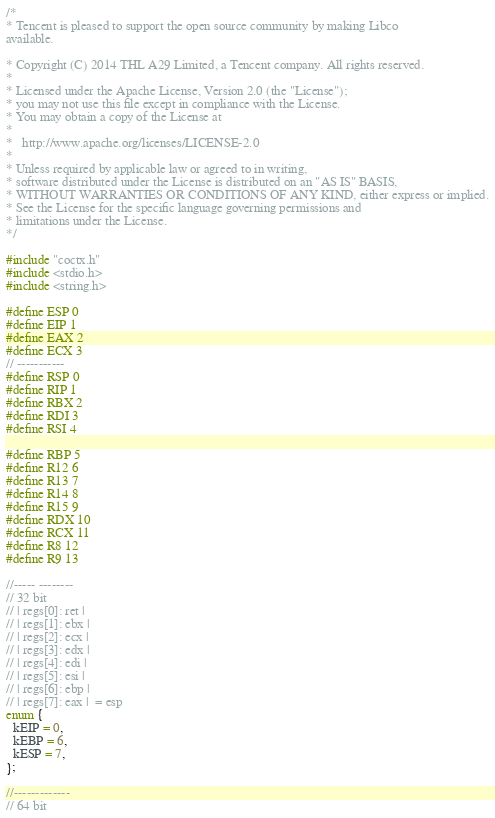<code> <loc_0><loc_0><loc_500><loc_500><_C++_>/*
* Tencent is pleased to support the open source community by making Libco
available.

* Copyright (C) 2014 THL A29 Limited, a Tencent company. All rights reserved.
*
* Licensed under the Apache License, Version 2.0 (the "License");
* you may not use this file except in compliance with the License.
* You may obtain a copy of the License at
*
*	http://www.apache.org/licenses/LICENSE-2.0
*
* Unless required by applicable law or agreed to in writing,
* software distributed under the License is distributed on an "AS IS" BASIS,
* WITHOUT WARRANTIES OR CONDITIONS OF ANY KIND, either express or implied.
* See the License for the specific language governing permissions and
* limitations under the License.
*/

#include "coctx.h"
#include <stdio.h>
#include <string.h>

#define ESP 0
#define EIP 1
#define EAX 2
#define ECX 3
// -----------
#define RSP 0
#define RIP 1
#define RBX 2
#define RDI 3
#define RSI 4

#define RBP 5
#define R12 6
#define R13 7
#define R14 8
#define R15 9
#define RDX 10
#define RCX 11
#define R8 12
#define R9 13

//----- --------
// 32 bit
// | regs[0]: ret |
// | regs[1]: ebx |
// | regs[2]: ecx |
// | regs[3]: edx |
// | regs[4]: edi |
// | regs[5]: esi |
// | regs[6]: ebp |
// | regs[7]: eax |  = esp
enum {
  kEIP = 0,
  kEBP = 6,
  kESP = 7,
};

//-------------
// 64 bit</code> 